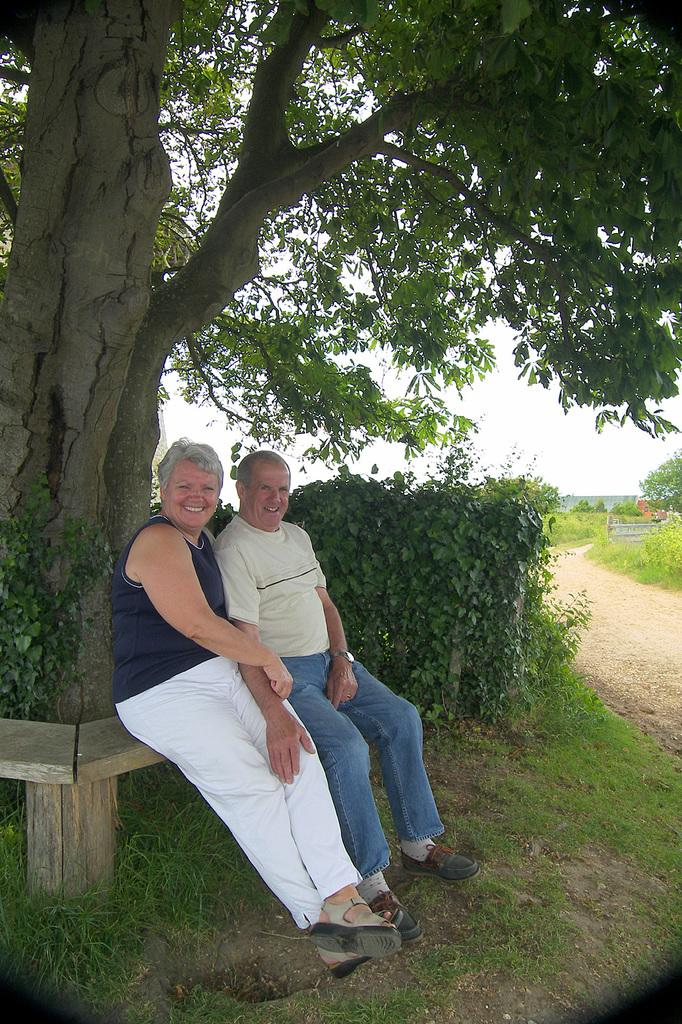Who is present in the image? There is a couple in the image. What are the couple doing in the image? The couple is sitting on a bench. Where is the bench located in the image? The bench is under a tree. What else can be seen in the image besides the couple and the bench? There are plants and other trees in the image. What type of discussion is the couple having about their thumbs in the image? There is no indication in the image that the couple is having a discussion about their thumbs or any other topic. 